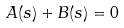Convert formula to latex. <formula><loc_0><loc_0><loc_500><loc_500>A ( s ) + B ( s ) = 0</formula> 